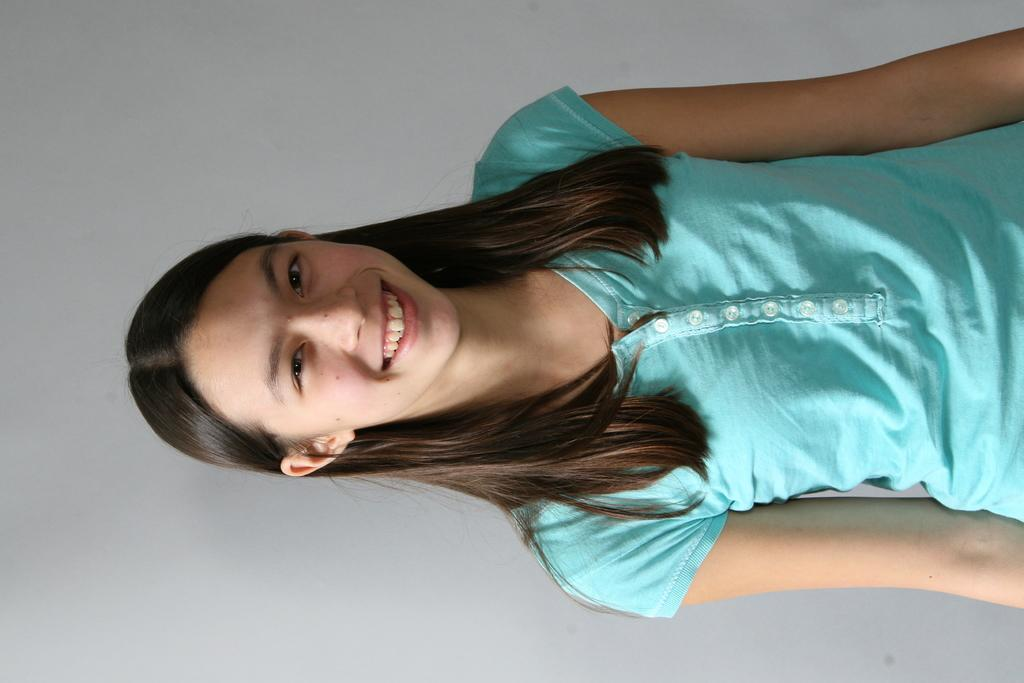What is the main subject of the image? There is a girl standing in the image. What is the girl doing in the image? The girl is smiling in the image. Where is the girl located in the image? The girl is in the middle of the image. What can be seen in the background of the image? There is a wall in the background of the image. What type of coat is the girl wearing in the image? There is no coat visible in the image; the girl is not wearing any outerwear. 